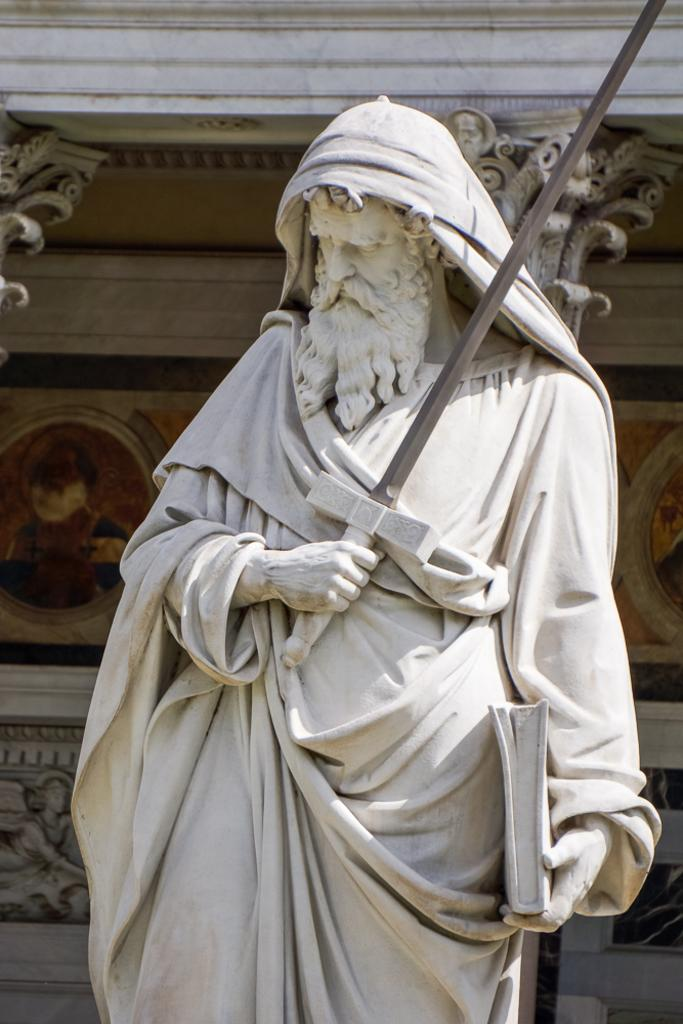What is the main subject in the center of the image? There is a sculpture in the center of the image. What can be seen in the background of the image? There is a wall in the background of the image. How many owls are perched on the sculpture in the image? There are no owls present in the image; the main subject is a sculpture. 